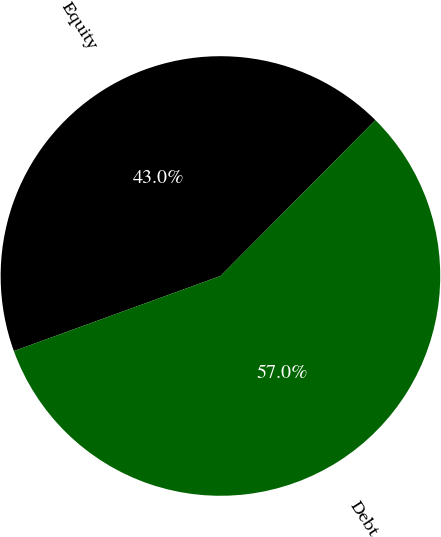Convert chart to OTSL. <chart><loc_0><loc_0><loc_500><loc_500><pie_chart><fcel>Equity<fcel>Debt<nl><fcel>43.0%<fcel>57.0%<nl></chart> 